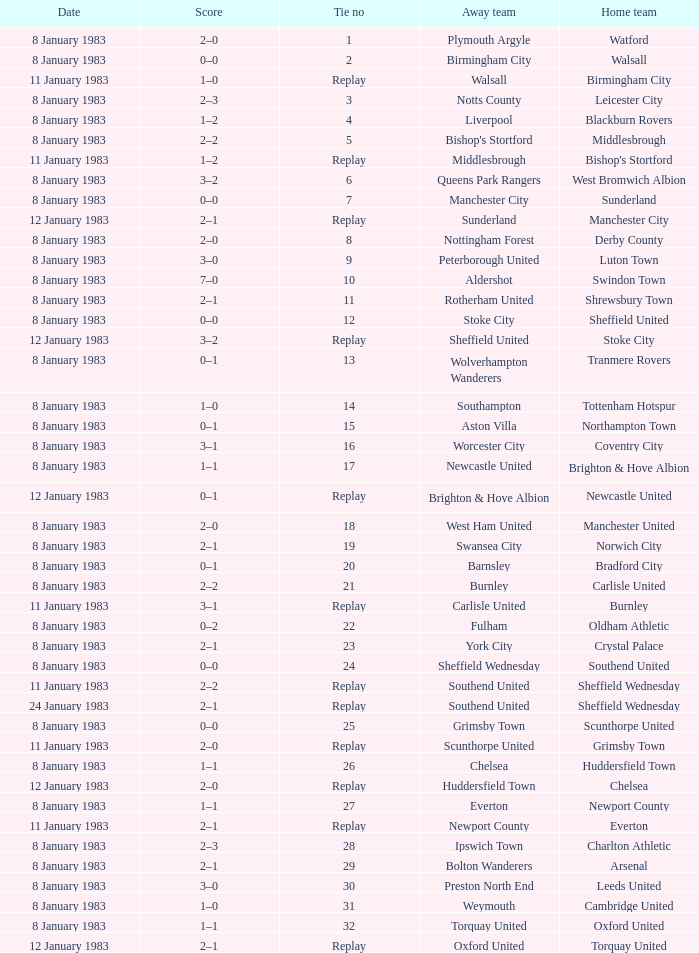Parse the table in full. {'header': ['Date', 'Score', 'Tie no', 'Away team', 'Home team'], 'rows': [['8 January 1983', '2–0', '1', 'Plymouth Argyle', 'Watford'], ['8 January 1983', '0–0', '2', 'Birmingham City', 'Walsall'], ['11 January 1983', '1–0', 'Replay', 'Walsall', 'Birmingham City'], ['8 January 1983', '2–3', '3', 'Notts County', 'Leicester City'], ['8 January 1983', '1–2', '4', 'Liverpool', 'Blackburn Rovers'], ['8 January 1983', '2–2', '5', "Bishop's Stortford", 'Middlesbrough'], ['11 January 1983', '1–2', 'Replay', 'Middlesbrough', "Bishop's Stortford"], ['8 January 1983', '3–2', '6', 'Queens Park Rangers', 'West Bromwich Albion'], ['8 January 1983', '0–0', '7', 'Manchester City', 'Sunderland'], ['12 January 1983', '2–1', 'Replay', 'Sunderland', 'Manchester City'], ['8 January 1983', '2–0', '8', 'Nottingham Forest', 'Derby County'], ['8 January 1983', '3–0', '9', 'Peterborough United', 'Luton Town'], ['8 January 1983', '7–0', '10', 'Aldershot', 'Swindon Town'], ['8 January 1983', '2–1', '11', 'Rotherham United', 'Shrewsbury Town'], ['8 January 1983', '0–0', '12', 'Stoke City', 'Sheffield United'], ['12 January 1983', '3–2', 'Replay', 'Sheffield United', 'Stoke City'], ['8 January 1983', '0–1', '13', 'Wolverhampton Wanderers', 'Tranmere Rovers'], ['8 January 1983', '1–0', '14', 'Southampton', 'Tottenham Hotspur'], ['8 January 1983', '0–1', '15', 'Aston Villa', 'Northampton Town'], ['8 January 1983', '3–1', '16', 'Worcester City', 'Coventry City'], ['8 January 1983', '1–1', '17', 'Newcastle United', 'Brighton & Hove Albion'], ['12 January 1983', '0–1', 'Replay', 'Brighton & Hove Albion', 'Newcastle United'], ['8 January 1983', '2–0', '18', 'West Ham United', 'Manchester United'], ['8 January 1983', '2–1', '19', 'Swansea City', 'Norwich City'], ['8 January 1983', '0–1', '20', 'Barnsley', 'Bradford City'], ['8 January 1983', '2–2', '21', 'Burnley', 'Carlisle United'], ['11 January 1983', '3–1', 'Replay', 'Carlisle United', 'Burnley'], ['8 January 1983', '0–2', '22', 'Fulham', 'Oldham Athletic'], ['8 January 1983', '2–1', '23', 'York City', 'Crystal Palace'], ['8 January 1983', '0–0', '24', 'Sheffield Wednesday', 'Southend United'], ['11 January 1983', '2–2', 'Replay', 'Southend United', 'Sheffield Wednesday'], ['24 January 1983', '2–1', 'Replay', 'Southend United', 'Sheffield Wednesday'], ['8 January 1983', '0–0', '25', 'Grimsby Town', 'Scunthorpe United'], ['11 January 1983', '2–0', 'Replay', 'Scunthorpe United', 'Grimsby Town'], ['8 January 1983', '1–1', '26', 'Chelsea', 'Huddersfield Town'], ['12 January 1983', '2–0', 'Replay', 'Huddersfield Town', 'Chelsea'], ['8 January 1983', '1–1', '27', 'Everton', 'Newport County'], ['11 January 1983', '2–1', 'Replay', 'Newport County', 'Everton'], ['8 January 1983', '2–3', '28', 'Ipswich Town', 'Charlton Athletic'], ['8 January 1983', '2–1', '29', 'Bolton Wanderers', 'Arsenal'], ['8 January 1983', '3–0', '30', 'Preston North End', 'Leeds United'], ['8 January 1983', '1–0', '31', 'Weymouth', 'Cambridge United'], ['8 January 1983', '1–1', '32', 'Torquay United', 'Oxford United'], ['12 January 1983', '2–1', 'Replay', 'Oxford United', 'Torquay United']]} In the tie where Southampton was the away team, who was the home team? Tottenham Hotspur. 